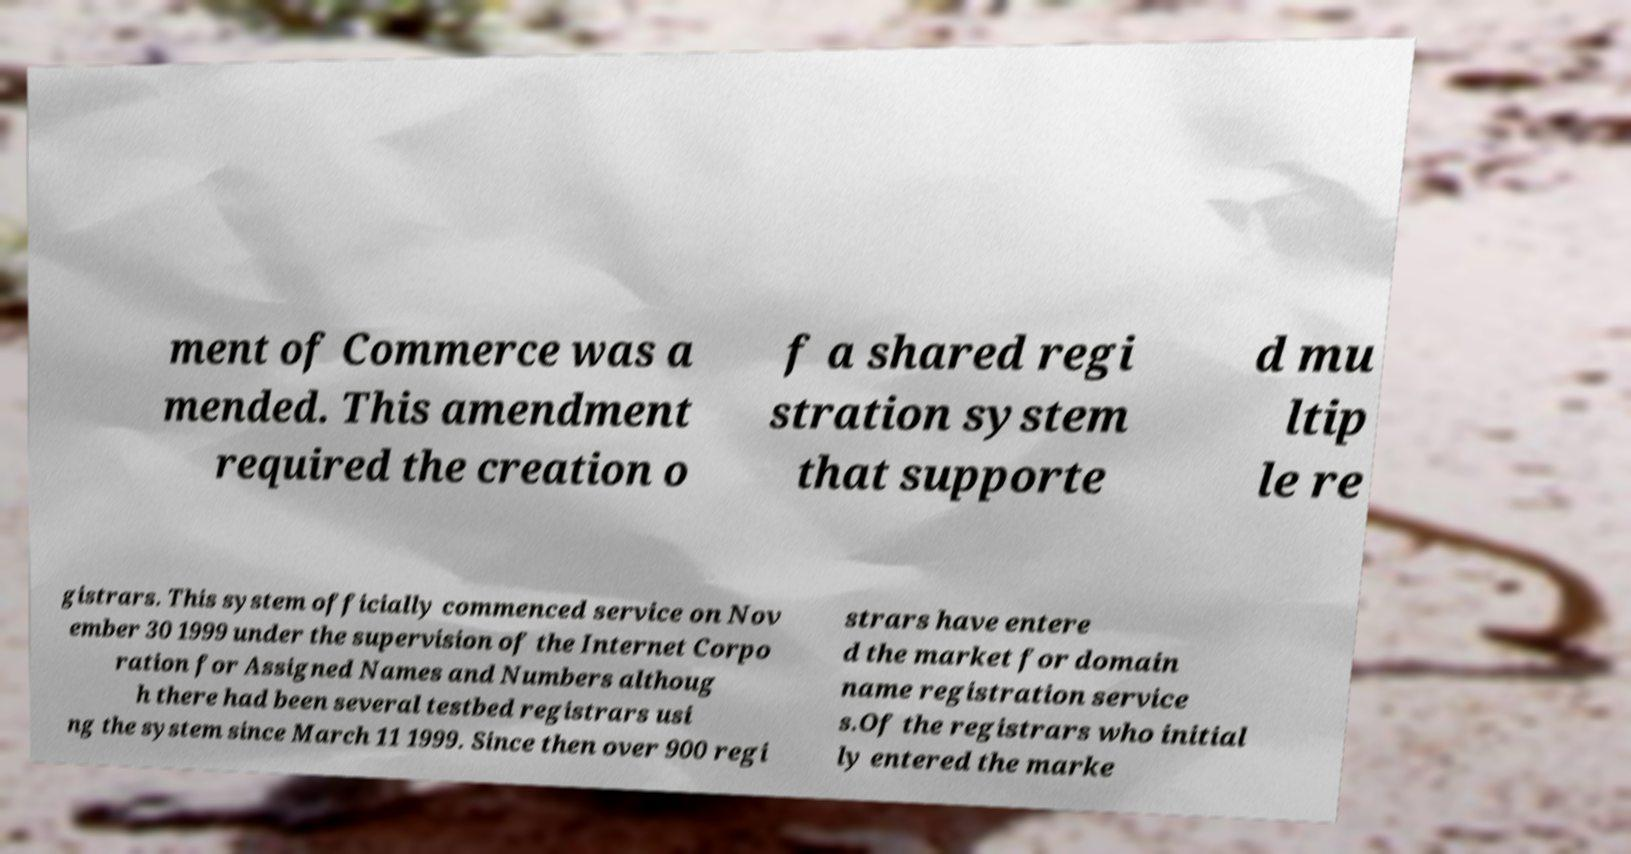I need the written content from this picture converted into text. Can you do that? ment of Commerce was a mended. This amendment required the creation o f a shared regi stration system that supporte d mu ltip le re gistrars. This system officially commenced service on Nov ember 30 1999 under the supervision of the Internet Corpo ration for Assigned Names and Numbers althoug h there had been several testbed registrars usi ng the system since March 11 1999. Since then over 900 regi strars have entere d the market for domain name registration service s.Of the registrars who initial ly entered the marke 